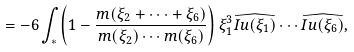<formula> <loc_0><loc_0><loc_500><loc_500>= - 6 \int _ { \ast } \left ( 1 - \frac { m ( \xi _ { 2 } + \cdots + \xi _ { 6 } ) } { m ( \xi _ { 2 } ) \cdots m ( \xi _ { 6 } ) } \right ) \xi _ { 1 } ^ { 3 } \widehat { I u ( \xi _ { 1 } ) } \cdots \widehat { I u ( \xi _ { 6 } ) } ,</formula> 